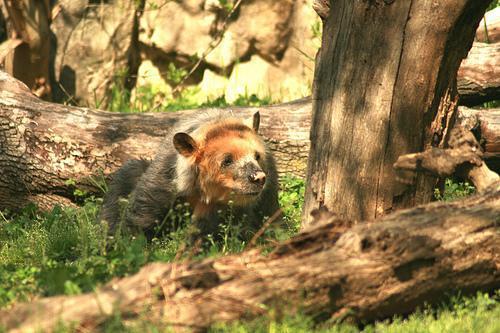How many animals are shown?
Give a very brief answer. 1. How many logs are shown?
Give a very brief answer. 3. 